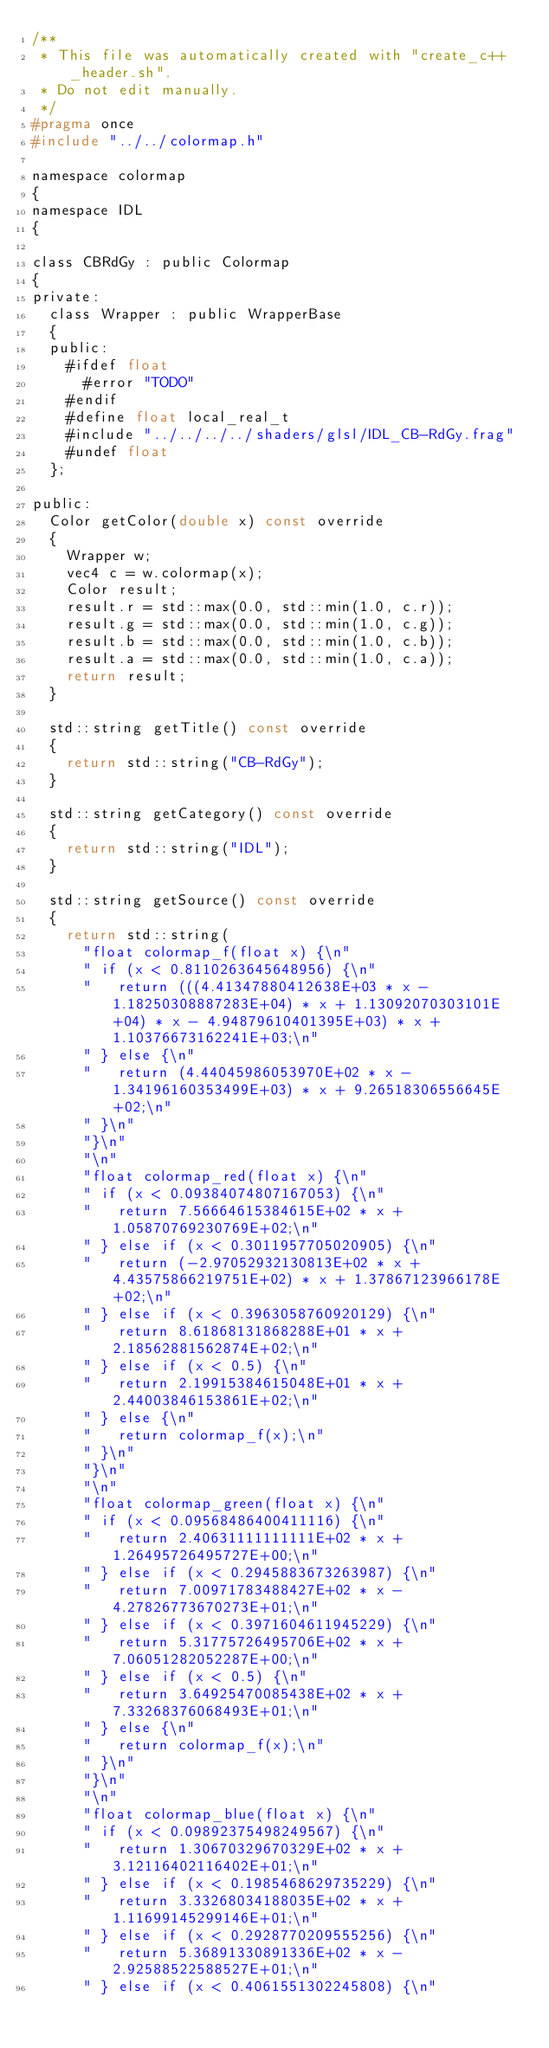<code> <loc_0><loc_0><loc_500><loc_500><_C_>/**
 * This file was automatically created with "create_c++_header.sh".
 * Do not edit manually.
 */
#pragma once
#include "../../colormap.h"

namespace colormap
{
namespace IDL
{

class CBRdGy : public Colormap
{
private:
	class Wrapper : public WrapperBase
	{
	public:
		#ifdef float
			#error "TODO"
		#endif
		#define float local_real_t
		#include "../../../../shaders/glsl/IDL_CB-RdGy.frag"
		#undef float
	};

public:
	Color getColor(double x) const override
	{
		Wrapper w;
		vec4 c = w.colormap(x);
		Color result;
		result.r = std::max(0.0, std::min(1.0, c.r));
		result.g = std::max(0.0, std::min(1.0, c.g));
		result.b = std::max(0.0, std::min(1.0, c.b));
		result.a = std::max(0.0, std::min(1.0, c.a));
		return result;
	}

	std::string getTitle() const override
	{
		return std::string("CB-RdGy");
	}

	std::string getCategory() const override
	{
		return std::string("IDL");
	}

	std::string getSource() const override
	{
		return std::string(
			"float colormap_f(float x) {\n"
			"	if (x < 0.8110263645648956) {\n"
			"		return (((4.41347880412638E+03 * x - 1.18250308887283E+04) * x + 1.13092070303101E+04) * x - 4.94879610401395E+03) * x + 1.10376673162241E+03;\n"
			"	} else {\n"
			"		return (4.44045986053970E+02 * x - 1.34196160353499E+03) * x + 9.26518306556645E+02;\n"
			"	}\n"
			"}\n"
			"\n"
			"float colormap_red(float x) {\n"
			"	if (x < 0.09384074807167053) {\n"
			"		return 7.56664615384615E+02 * x + 1.05870769230769E+02;\n"
			"	} else if (x < 0.3011957705020905) {\n"
			"		return (-2.97052932130813E+02 * x + 4.43575866219751E+02) * x + 1.37867123966178E+02;\n"
			"	} else if (x < 0.3963058760920129) {\n"
			"		return 8.61868131868288E+01 * x + 2.18562881562874E+02;\n"
			"	} else if (x < 0.5) {\n"
			"		return 2.19915384615048E+01 * x + 2.44003846153861E+02;\n"
			"	} else {\n"
			"		return colormap_f(x);\n"
			"	}\n"
			"}\n"
			"\n"
			"float colormap_green(float x) {\n"
			"	if (x < 0.09568486400411116) {\n"
			"		return 2.40631111111111E+02 * x + 1.26495726495727E+00;\n"
			"	} else if (x < 0.2945883673263987) {\n"
			"		return 7.00971783488427E+02 * x - 4.27826773670273E+01;\n"
			"	} else if (x < 0.3971604611945229) {\n"
			"		return 5.31775726495706E+02 * x + 7.06051282052287E+00;\n"
			"	} else if (x < 0.5) {\n"
			"		return 3.64925470085438E+02 * x + 7.33268376068493E+01;\n"
			"	} else {\n"
			"		return colormap_f(x);\n"
			"	}\n"
			"}\n"
			"\n"
			"float colormap_blue(float x) {\n"
			"	if (x < 0.09892375498249567) {\n"
			"		return 1.30670329670329E+02 * x + 3.12116402116402E+01;\n"
			"	} else if (x < 0.1985468629735229) {\n"
			"		return 3.33268034188035E+02 * x + 1.11699145299146E+01;\n"
			"	} else if (x < 0.2928770209555256) {\n"
			"		return 5.36891330891336E+02 * x - 2.92588522588527E+01;\n"
			"	} else if (x < 0.4061551302245808) {\n"</code> 